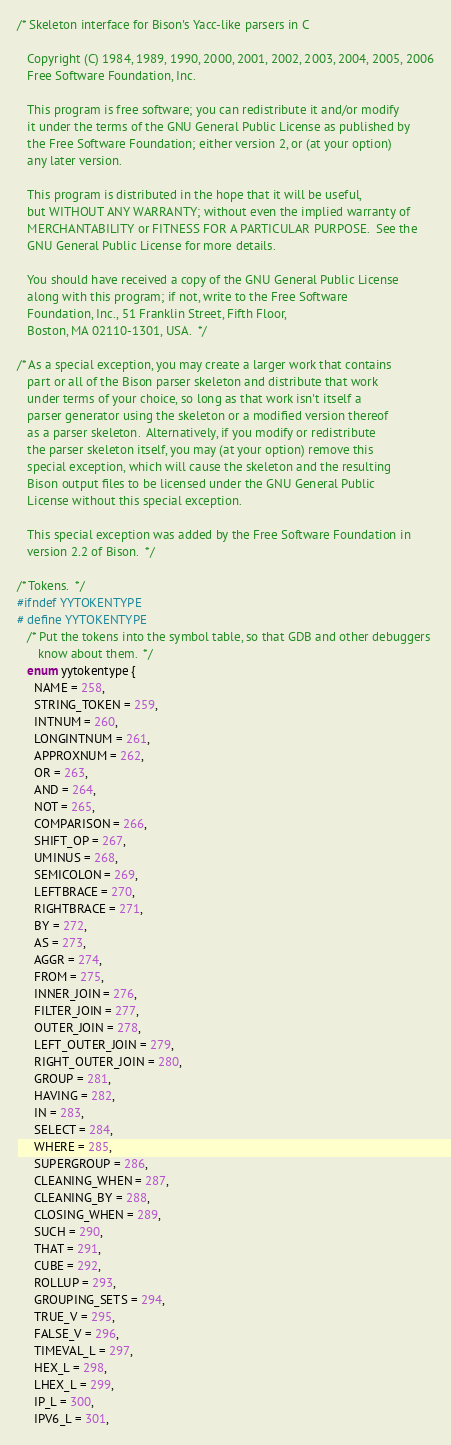Convert code to text. <code><loc_0><loc_0><loc_500><loc_500><_C_>/* Skeleton interface for Bison's Yacc-like parsers in C

   Copyright (C) 1984, 1989, 1990, 2000, 2001, 2002, 2003, 2004, 2005, 2006
   Free Software Foundation, Inc.

   This program is free software; you can redistribute it and/or modify
   it under the terms of the GNU General Public License as published by
   the Free Software Foundation; either version 2, or (at your option)
   any later version.

   This program is distributed in the hope that it will be useful,
   but WITHOUT ANY WARRANTY; without even the implied warranty of
   MERCHANTABILITY or FITNESS FOR A PARTICULAR PURPOSE.  See the
   GNU General Public License for more details.

   You should have received a copy of the GNU General Public License
   along with this program; if not, write to the Free Software
   Foundation, Inc., 51 Franklin Street, Fifth Floor,
   Boston, MA 02110-1301, USA.  */

/* As a special exception, you may create a larger work that contains
   part or all of the Bison parser skeleton and distribute that work
   under terms of your choice, so long as that work isn't itself a
   parser generator using the skeleton or a modified version thereof
   as a parser skeleton.  Alternatively, if you modify or redistribute
   the parser skeleton itself, you may (at your option) remove this
   special exception, which will cause the skeleton and the resulting
   Bison output files to be licensed under the GNU General Public
   License without this special exception.

   This special exception was added by the Free Software Foundation in
   version 2.2 of Bison.  */

/* Tokens.  */
#ifndef YYTOKENTYPE
# define YYTOKENTYPE
   /* Put the tokens into the symbol table, so that GDB and other debuggers
      know about them.  */
   enum yytokentype {
     NAME = 258,
     STRING_TOKEN = 259,
     INTNUM = 260,
     LONGINTNUM = 261,
     APPROXNUM = 262,
     OR = 263,
     AND = 264,
     NOT = 265,
     COMPARISON = 266,
     SHIFT_OP = 267,
     UMINUS = 268,
     SEMICOLON = 269,
     LEFTBRACE = 270,
     RIGHTBRACE = 271,
     BY = 272,
     AS = 273,
     AGGR = 274,
     FROM = 275,
     INNER_JOIN = 276,
     FILTER_JOIN = 277,
     OUTER_JOIN = 278,
     LEFT_OUTER_JOIN = 279,
     RIGHT_OUTER_JOIN = 280,
     GROUP = 281,
     HAVING = 282,
     IN = 283,
     SELECT = 284,
     WHERE = 285,
     SUPERGROUP = 286,
     CLEANING_WHEN = 287,
     CLEANING_BY = 288,
     CLOSING_WHEN = 289,
     SUCH = 290,
     THAT = 291,
     CUBE = 292,
     ROLLUP = 293,
     GROUPING_SETS = 294,
     TRUE_V = 295,
     FALSE_V = 296,
     TIMEVAL_L = 297,
     HEX_L = 298,
     LHEX_L = 299,
     IP_L = 300,
     IPV6_L = 301,</code> 